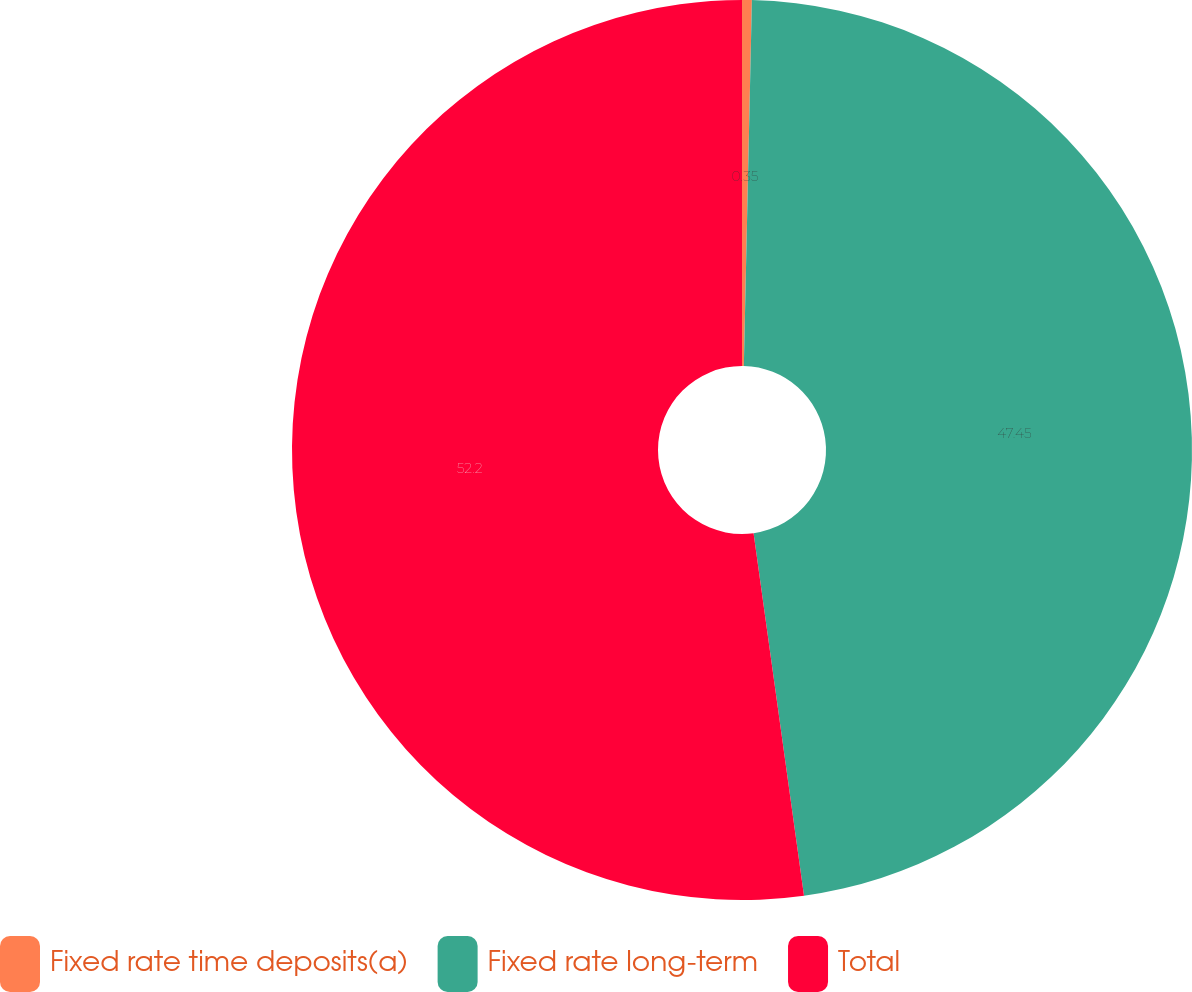Convert chart. <chart><loc_0><loc_0><loc_500><loc_500><pie_chart><fcel>Fixed rate time deposits(a)<fcel>Fixed rate long-term<fcel>Total<nl><fcel>0.35%<fcel>47.45%<fcel>52.2%<nl></chart> 